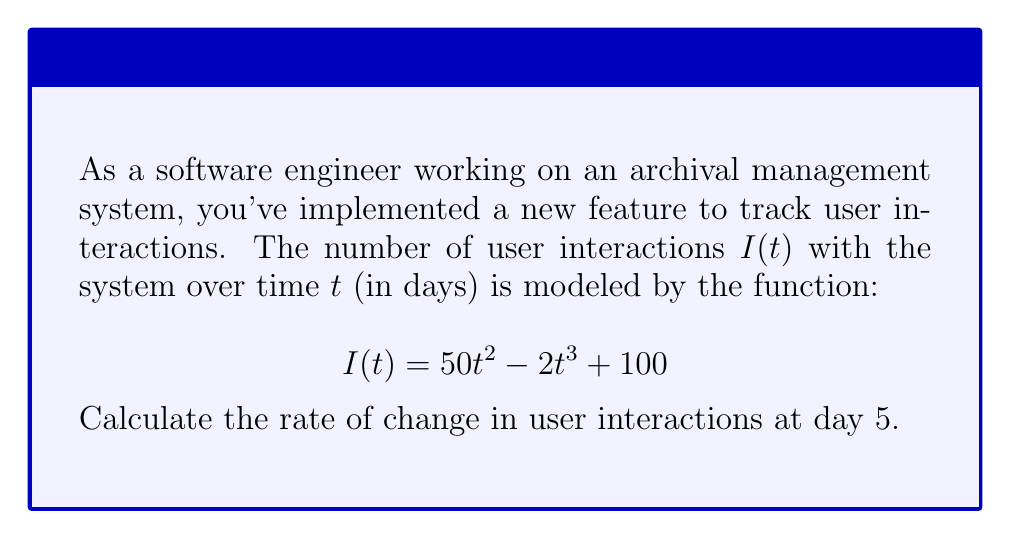Give your solution to this math problem. To find the rate of change in user interactions at day 5, we need to calculate the derivative of $I(t)$ and evaluate it at $t = 5$. Let's proceed step-by-step:

1) First, let's find the derivative of $I(t)$:
   
   $$I(t) = 50t^2 - 2t^3 + 100$$
   
   $$I'(t) = 100t - 6t^2$$

   We used the power rule: the derivative of $t^n$ is $nt^{n-1}$.

2) Now that we have $I'(t)$, we can evaluate it at $t = 5$:
   
   $$I'(5) = 100(5) - 6(5^2)$$

3) Let's calculate this:
   
   $$I'(5) = 500 - 6(25)$$
   $$I'(5) = 500 - 150$$
   $$I'(5) = 350$$

Therefore, the rate of change in user interactions at day 5 is 350 interactions per day.
Answer: 350 interactions/day 